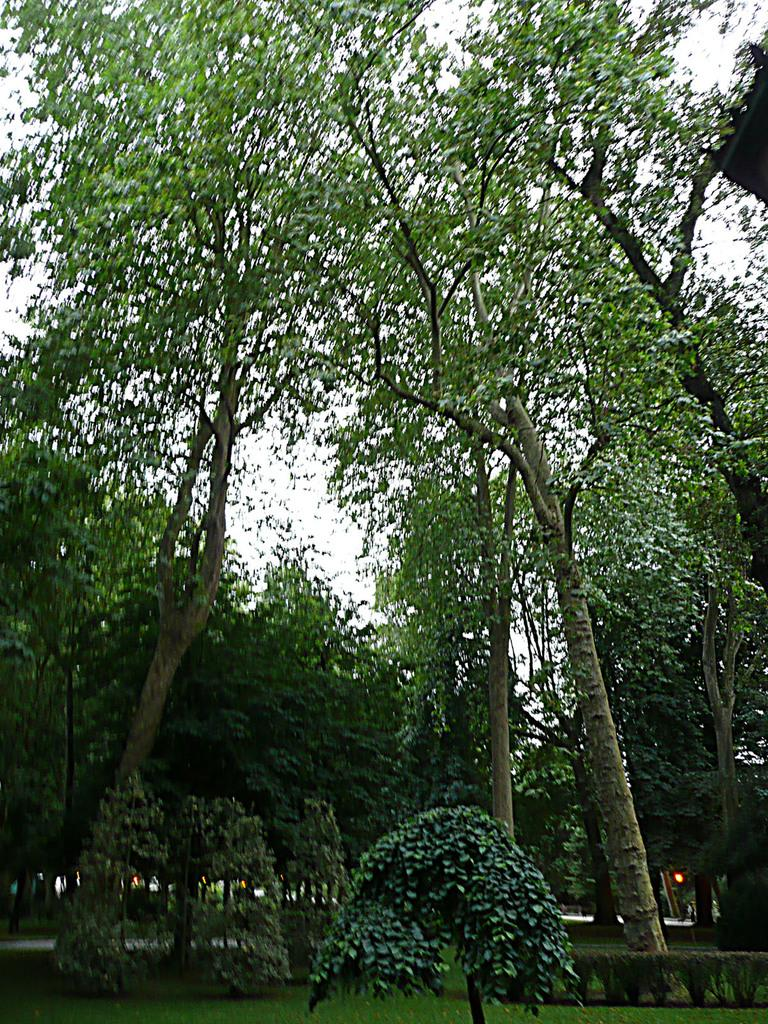What type of vegetation can be seen in the image? There are trees, plants, and grass in the image. What part of the natural environment is visible in the image? The sky is visible in the background of the image. What type of activity is taking place on the dock in the image? There is no dock present in the image; it features trees, plants, grass, and the sky. 